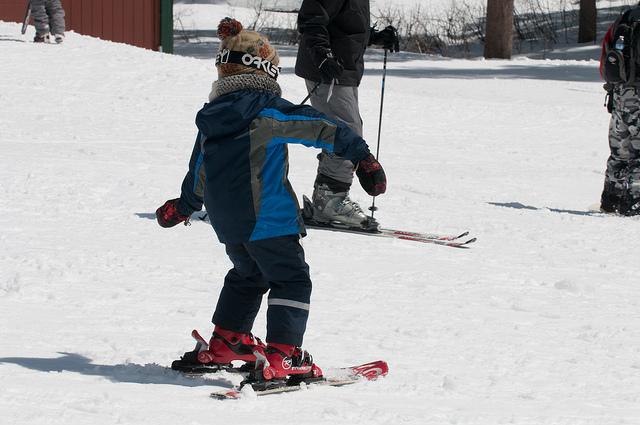What color is the child's skis?
Quick response, please. Red. How old is the child?
Concise answer only. 6. Is the child wearing a hat?
Keep it brief. Yes. 